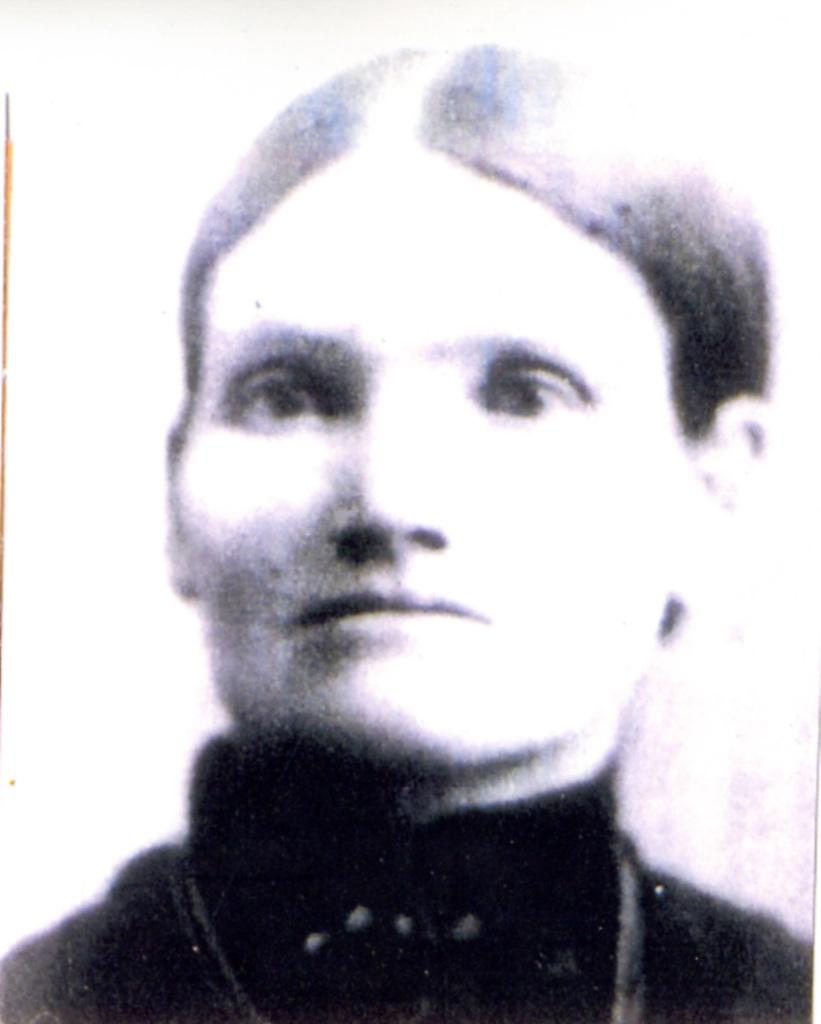What is the main subject of the image? The main subject of the image is a man. What is the man wearing in the image? The man is wearing a black dress in the image. What type of yam is being served in the hospital room in the image? There is no yam or hospital room present in the image; it features a man wearing a black dress. What root vegetable is being used as a decoration in the image? There is no root vegetable present in the image. 